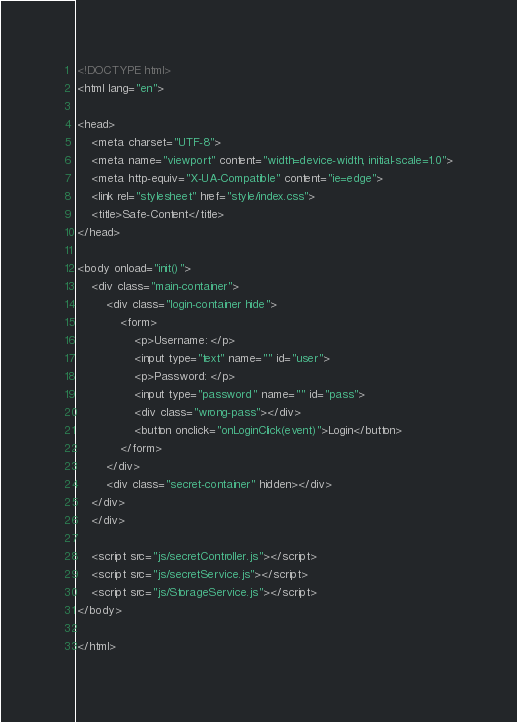Convert code to text. <code><loc_0><loc_0><loc_500><loc_500><_HTML_><!DOCTYPE html>
<html lang="en">

<head>
    <meta charset="UTF-8">
    <meta name="viewport" content="width=device-width, initial-scale=1.0">
    <meta http-equiv="X-UA-Compatible" content="ie=edge">
    <link rel="stylesheet" href="style/index.css">
    <title>Safe-Content</title>
</head>

<body onload="init()">
    <div class="main-container">
        <div class="login-container hide">
            <form>
                <p>Username: </p>
                <input type="text" name="" id="user">
                <p>Password: </p>
                <input type="password" name="" id="pass">
                <div class="wrong-pass"></div>
                <button onclick="onLoginClick(event)">Login</button>
            </form>
        </div>
        <div class="secret-container" hidden></div>
    </div>
    </div>

    <script src="js/secretController.js"></script>
    <script src="js/secretService.js"></script>
    <script src="js/StorageService.js"></script>
</body>

</html></code> 